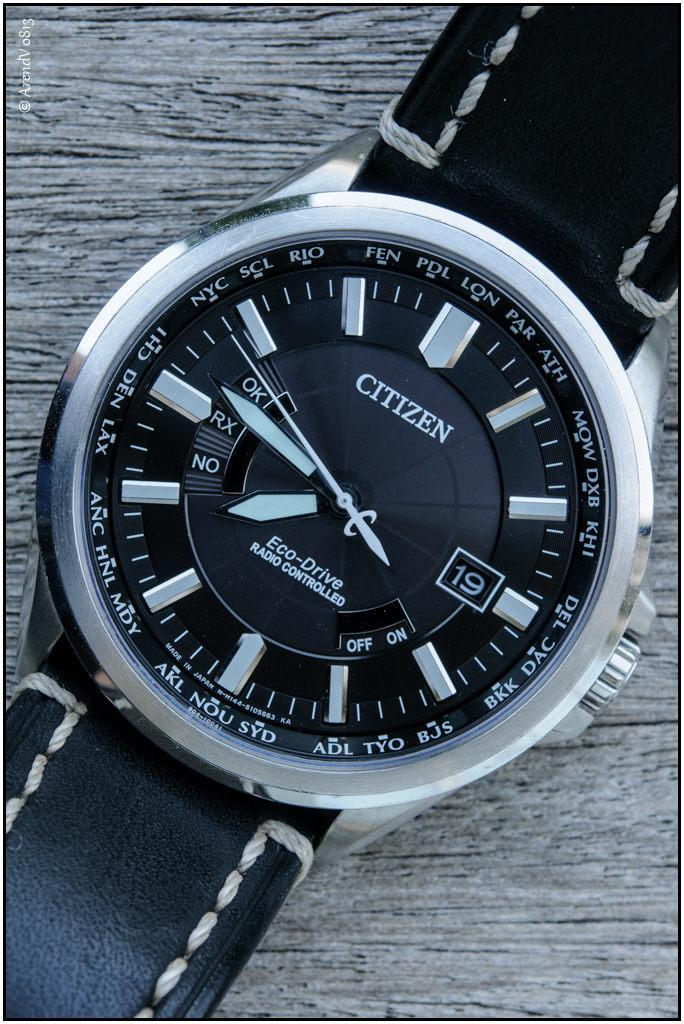<image>
Write a terse but informative summary of the picture. A Citizen watch with a black band lays on grey wood. 